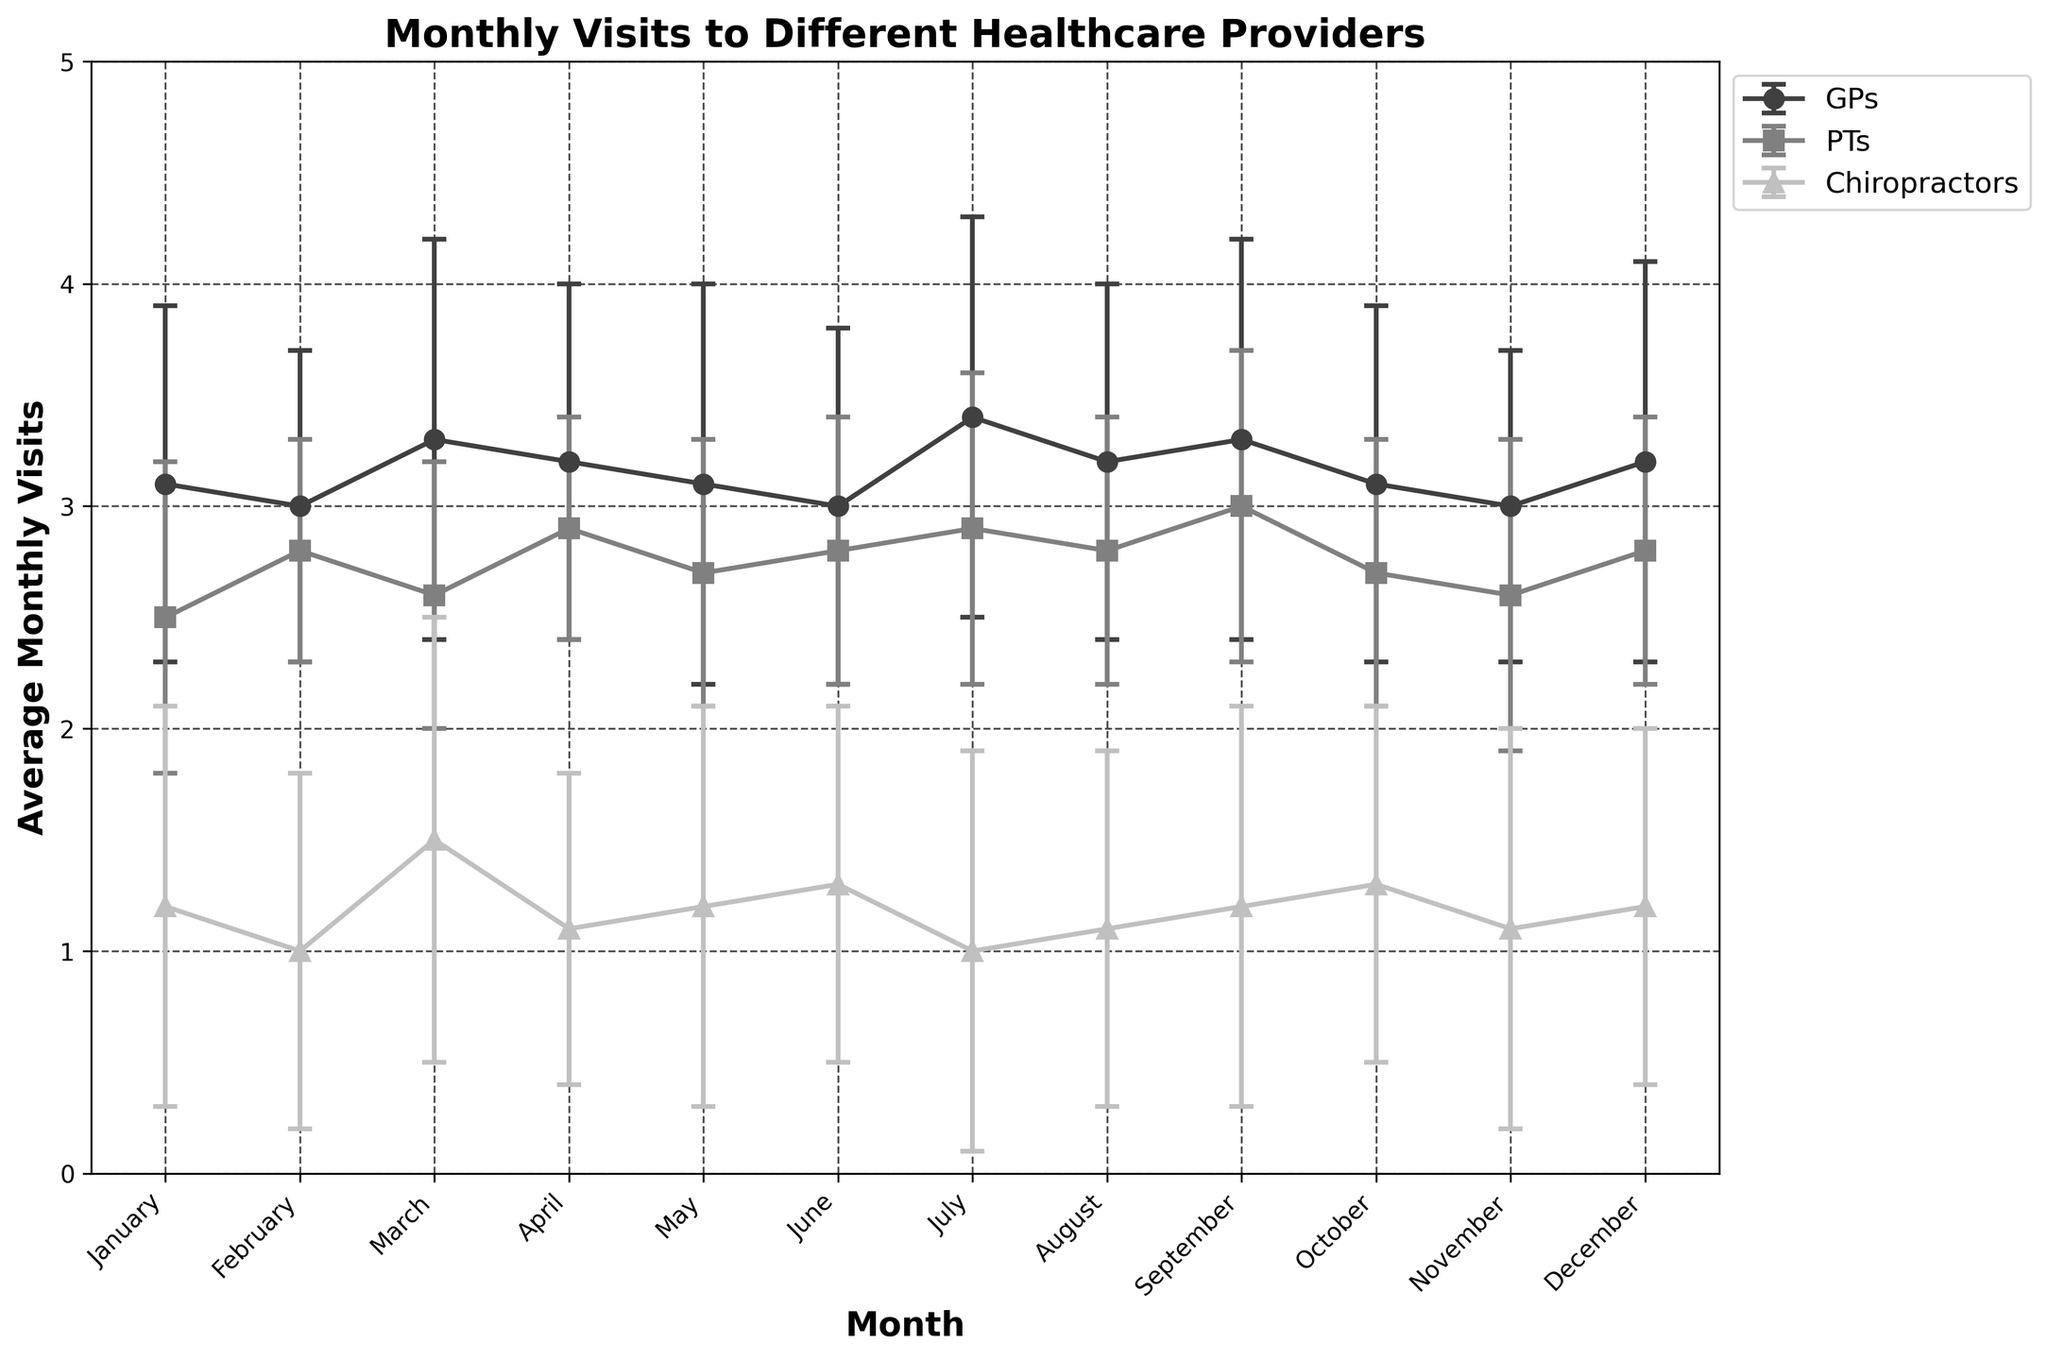what's the title of the figure? The title of the figure is displayed at the top of the chart and summarizes the content of the plot.
Answer: Monthly Visits to Different Healthcare Providers which month had the highest average visits to GPs? To find the month with the highest average visits to GPs, look at the line representing GPs and identify the month where the y-value is highest.
Answer: July how does the standard deviation for chiropractor visits in January compare to that in March? Compare the error bar lengths for chiropractor visits in January and March. The longer the error bar, the higher the standard deviation.
Answer: January's standard deviation is smaller than March's which healthcare provider had the most stable (least variable) visit numbers throughout the year? The provider with the smallest average error bars over the year is the most stable. Compare the visual lengths of all error bars for each provider throughout the year.
Answer: PTs what's the average number of monthly visits to PTs in February and April? Add the average visits for PTs in February and April, then divide by the number of months to find the average: (2.8 + 2.9) / 2.
Answer: 2.85 which month showed the greatest variability for chiropractor visits? Identify the month with the longest error bar for chiropractor visits, indicating the highest standard deviation.
Answer: March how do GP visits in January compare to November? Look at the positions of the GP line in January versus November in terms of their y-values to see which is higher or lower.
Answer: January visits are higher than November what is the trend of PT visits from January to December? Follow the PT line from January to December to determine if the visits increase, decrease, or stay stable over time.
Answer: PT visits are relatively stable with slight fluctuations in which two consecutive months do GPs have the least change in average visits? Find two consecutive months where the GP line is closest to being horizontal, implying the smallest number difference.
Answer: January to February if a person visited chiropractors 1.1 times on average in April with a standard deviation of 0.7, what could be a potential range for their visits? Given the average visits and standard deviation, the range (on average) would be the average plus or minus the standard deviation (1.1 ± 0.7).
Answer: 0.4 to 1.8 